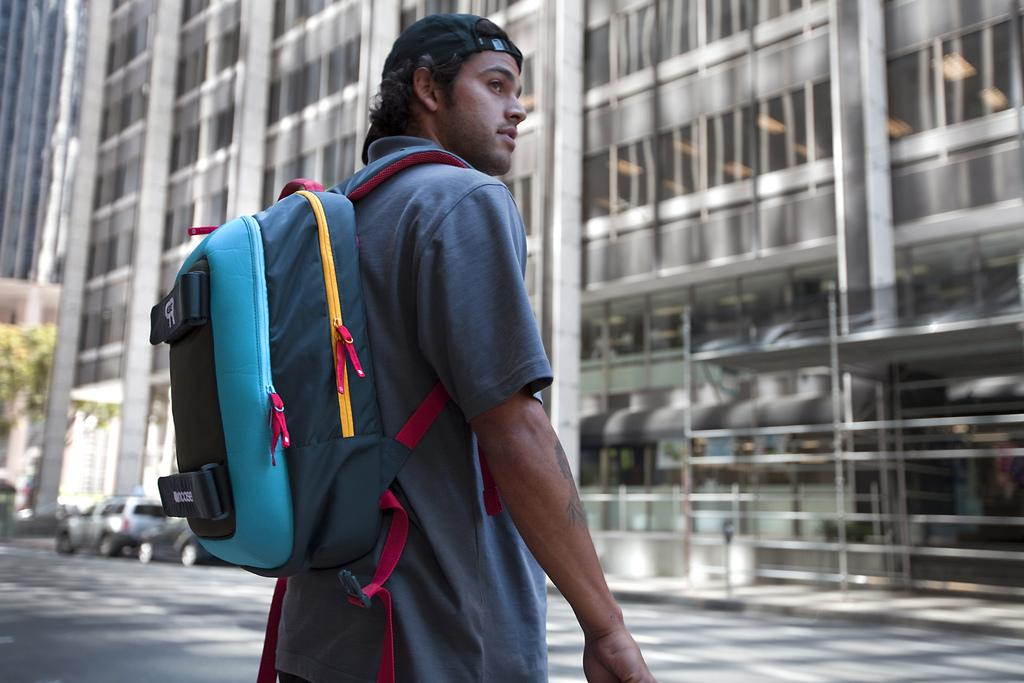Where was the image taken? The image was taken outside of the city. Can you describe the person in the image? The person in the image is standing and wearing a bag and a cap. What can be seen in the background of the image? There is a beautiful building, cars, and trees visible in the background of the image. What type of story is the queen telling in the image? There is no queen or story present in the image; it features a person standing outside of the city. 